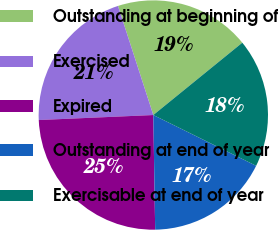Convert chart to OTSL. <chart><loc_0><loc_0><loc_500><loc_500><pie_chart><fcel>Outstanding at beginning of<fcel>Exercised<fcel>Expired<fcel>Outstanding at end of year<fcel>Exercisable at end of year<nl><fcel>19.12%<fcel>20.71%<fcel>24.56%<fcel>17.44%<fcel>18.16%<nl></chart> 